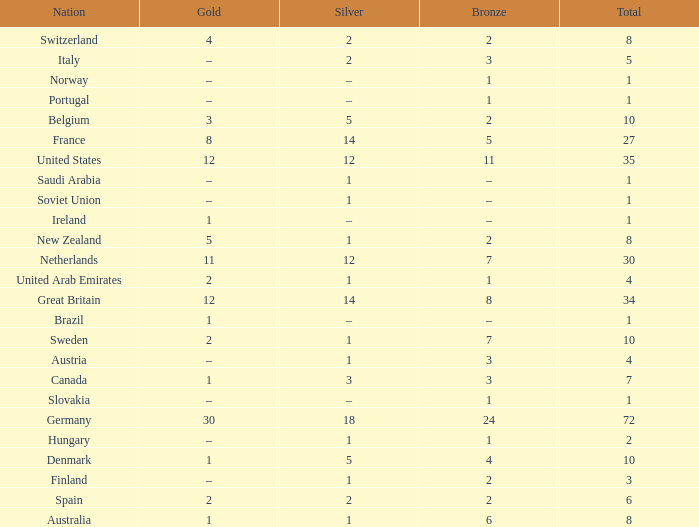What is Gold, when Silver is 5, and when Nation is Belgium? 3.0. 